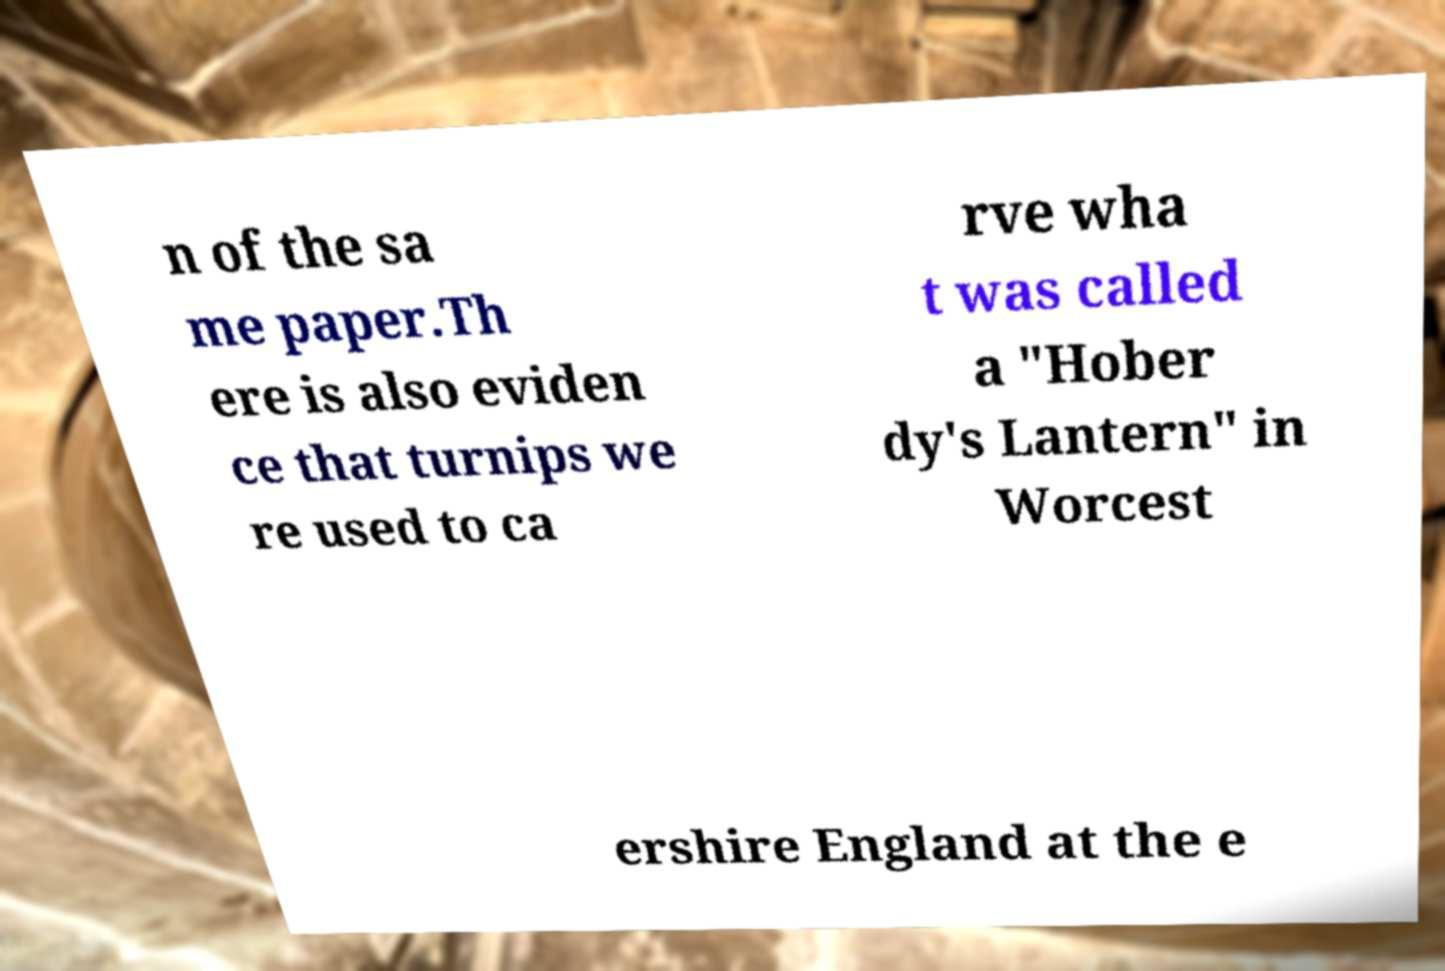Can you read and provide the text displayed in the image?This photo seems to have some interesting text. Can you extract and type it out for me? n of the sa me paper.Th ere is also eviden ce that turnips we re used to ca rve wha t was called a "Hober dy's Lantern" in Worcest ershire England at the e 